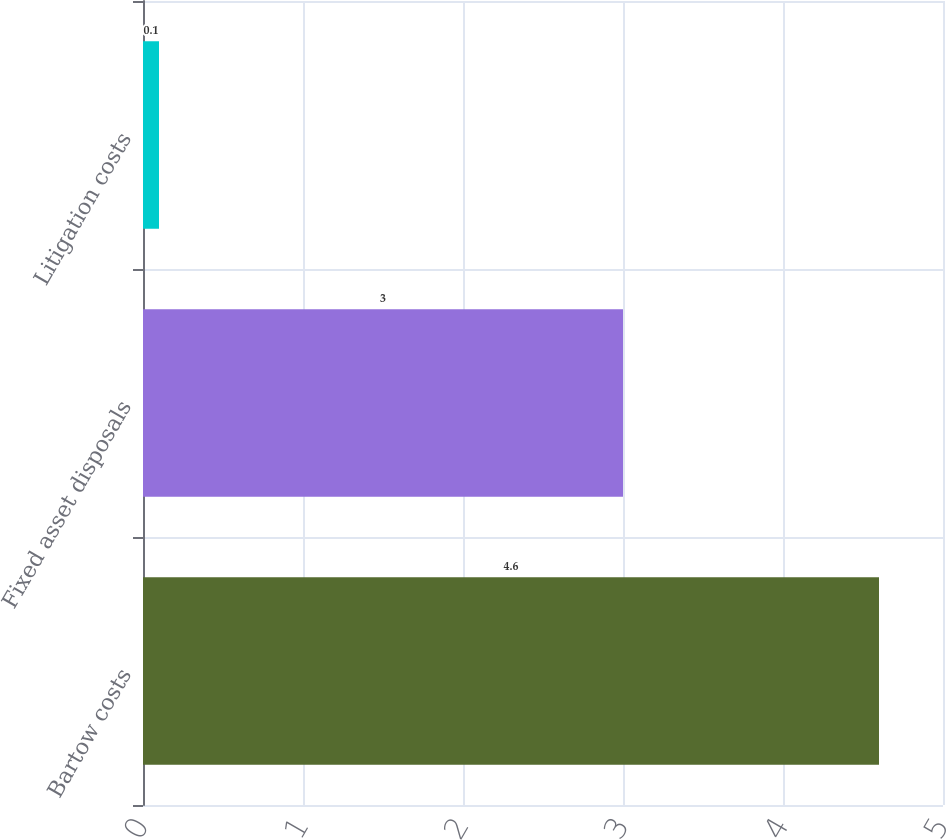Convert chart to OTSL. <chart><loc_0><loc_0><loc_500><loc_500><bar_chart><fcel>Bartow costs<fcel>Fixed asset disposals<fcel>Litigation costs<nl><fcel>4.6<fcel>3<fcel>0.1<nl></chart> 